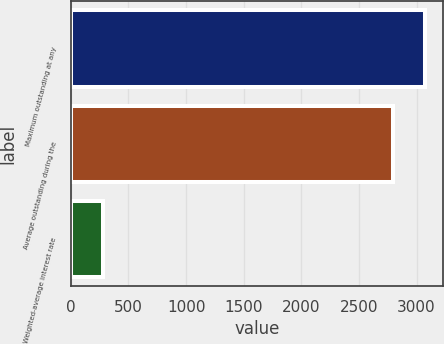Convert chart. <chart><loc_0><loc_0><loc_500><loc_500><bar_chart><fcel>Maximum outstanding at any<fcel>Average outstanding during the<fcel>Weighted-average interest rate<nl><fcel>3074.07<fcel>2791<fcel>283.38<nl></chart> 